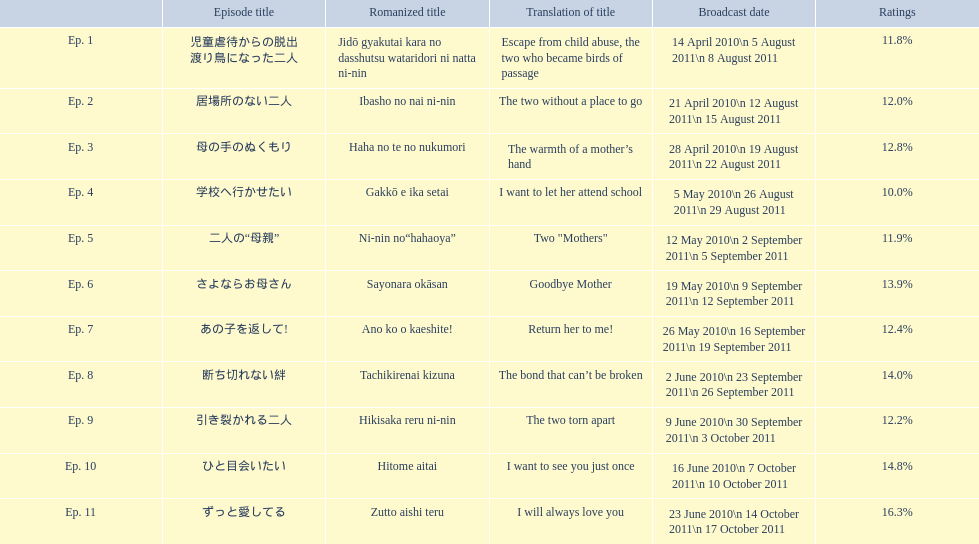Would you be able to parse every entry in this table? {'header': ['', 'Episode title', 'Romanized title', 'Translation of title', 'Broadcast date', 'Ratings'], 'rows': [['Ep. 1', '児童虐待からの脱出 渡り鳥になった二人', 'Jidō gyakutai kara no dasshutsu wataridori ni natta ni-nin', 'Escape from child abuse, the two who became birds of passage', '14 April 2010\\n 5 August 2011\\n 8 August 2011', '11.8%'], ['Ep. 2', '居場所のない二人', 'Ibasho no nai ni-nin', 'The two without a place to go', '21 April 2010\\n 12 August 2011\\n 15 August 2011', '12.0%'], ['Ep. 3', '母の手のぬくもり', 'Haha no te no nukumori', 'The warmth of a mother’s hand', '28 April 2010\\n 19 August 2011\\n 22 August 2011', '12.8%'], ['Ep. 4', '学校へ行かせたい', 'Gakkō e ika setai', 'I want to let her attend school', '5 May 2010\\n 26 August 2011\\n 29 August 2011', '10.0%'], ['Ep. 5', '二人の“母親”', 'Ni-nin no“hahaoya”', 'Two "Mothers"', '12 May 2010\\n 2 September 2011\\n 5 September 2011', '11.9%'], ['Ep. 6', 'さよならお母さん', 'Sayonara okāsan', 'Goodbye Mother', '19 May 2010\\n 9 September 2011\\n 12 September 2011', '13.9%'], ['Ep. 7', 'あの子を返して!', 'Ano ko o kaeshite!', 'Return her to me!', '26 May 2010\\n 16 September 2011\\n 19 September 2011', '12.4%'], ['Ep. 8', '断ち切れない絆', 'Tachikirenai kizuna', 'The bond that can’t be broken', '2 June 2010\\n 23 September 2011\\n 26 September 2011', '14.0%'], ['Ep. 9', '引き裂かれる二人', 'Hikisaka reru ni-nin', 'The two torn apart', '9 June 2010\\n 30 September 2011\\n 3 October 2011', '12.2%'], ['Ep. 10', 'ひと目会いたい', 'Hitome aitai', 'I want to see you just once', '16 June 2010\\n 7 October 2011\\n 10 October 2011', '14.8%'], ['Ep. 11', 'ずっと愛してる', 'Zutto aishi teru', 'I will always love you', '23 June 2010\\n 14 October 2011\\n 17 October 2011', '16.3%']]} What is the percentage of ratings for each episode? 11.8%, 12.0%, 12.8%, 10.0%, 11.9%, 13.9%, 12.4%, 14.0%, 12.2%, 14.8%, 16.3%. Which episode has the highest rating? 16.3%. Which episode scored a 16.3% rating? ずっと愛してる. 